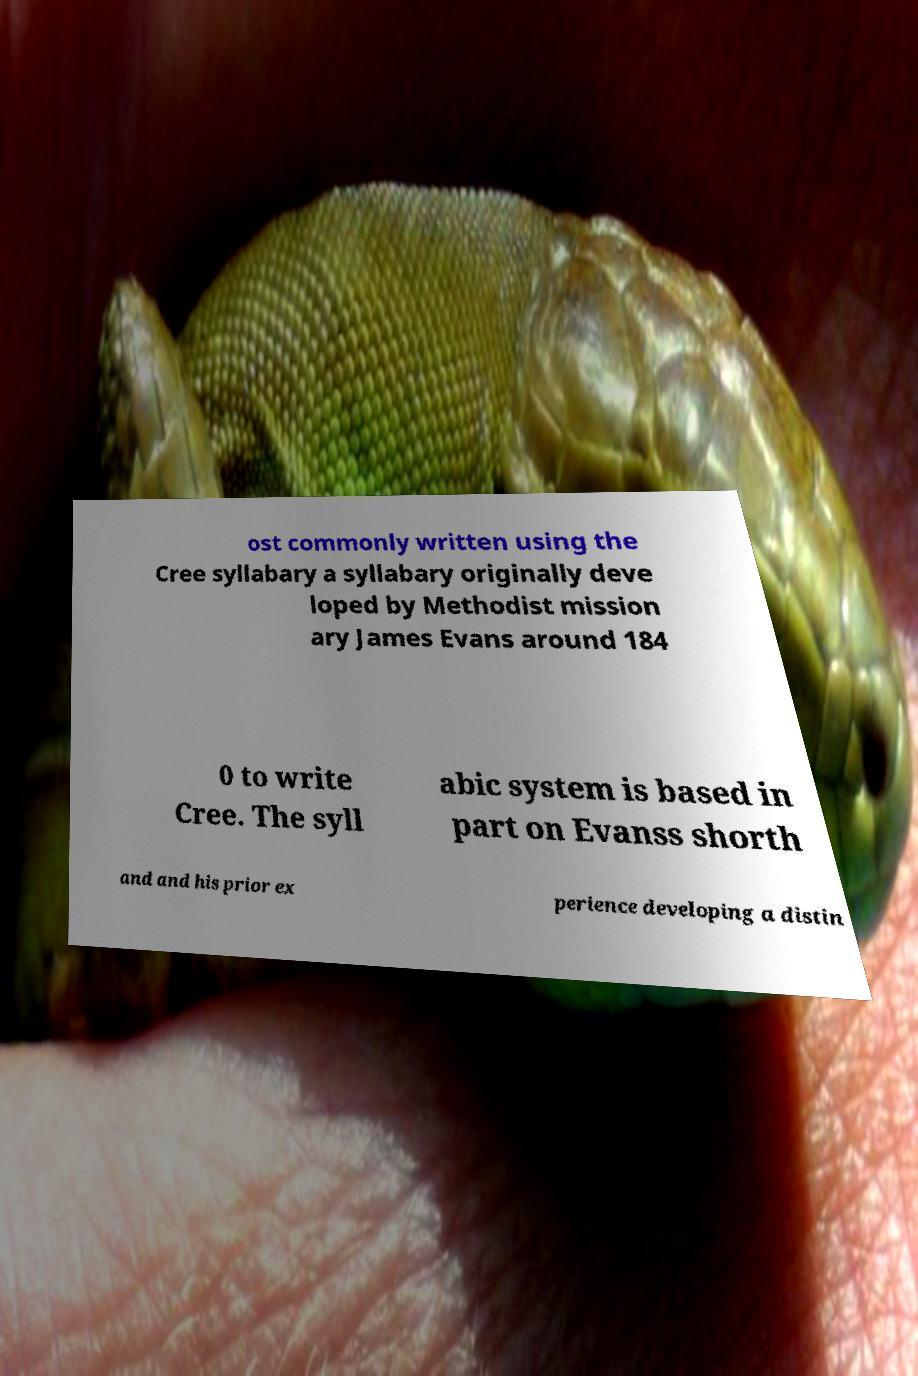I need the written content from this picture converted into text. Can you do that? ost commonly written using the Cree syllabary a syllabary originally deve loped by Methodist mission ary James Evans around 184 0 to write Cree. The syll abic system is based in part on Evanss shorth and and his prior ex perience developing a distin 